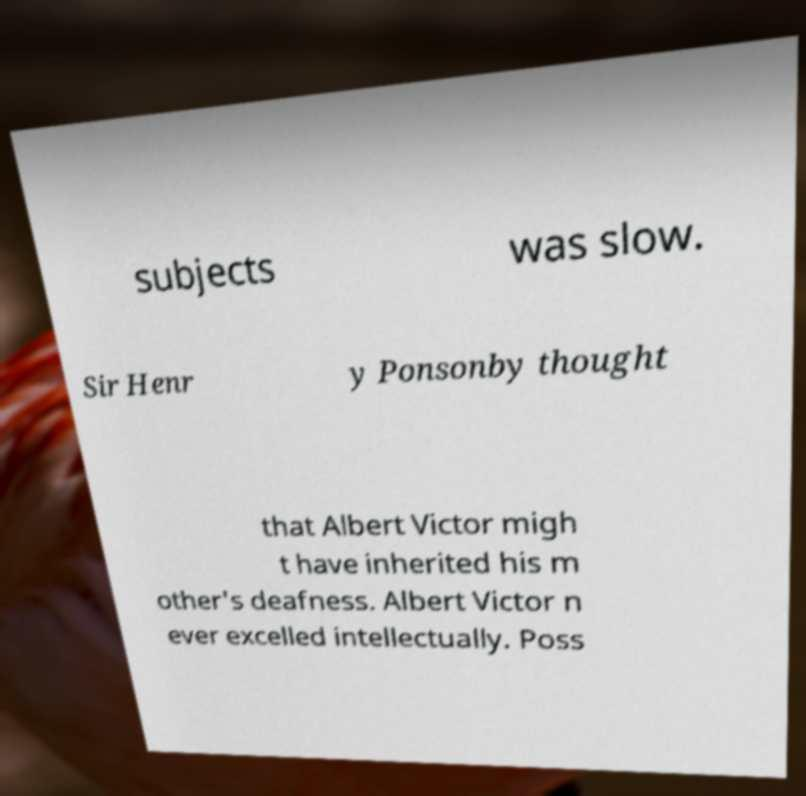What messages or text are displayed in this image? I need them in a readable, typed format. subjects was slow. Sir Henr y Ponsonby thought that Albert Victor migh t have inherited his m other's deafness. Albert Victor n ever excelled intellectually. Poss 